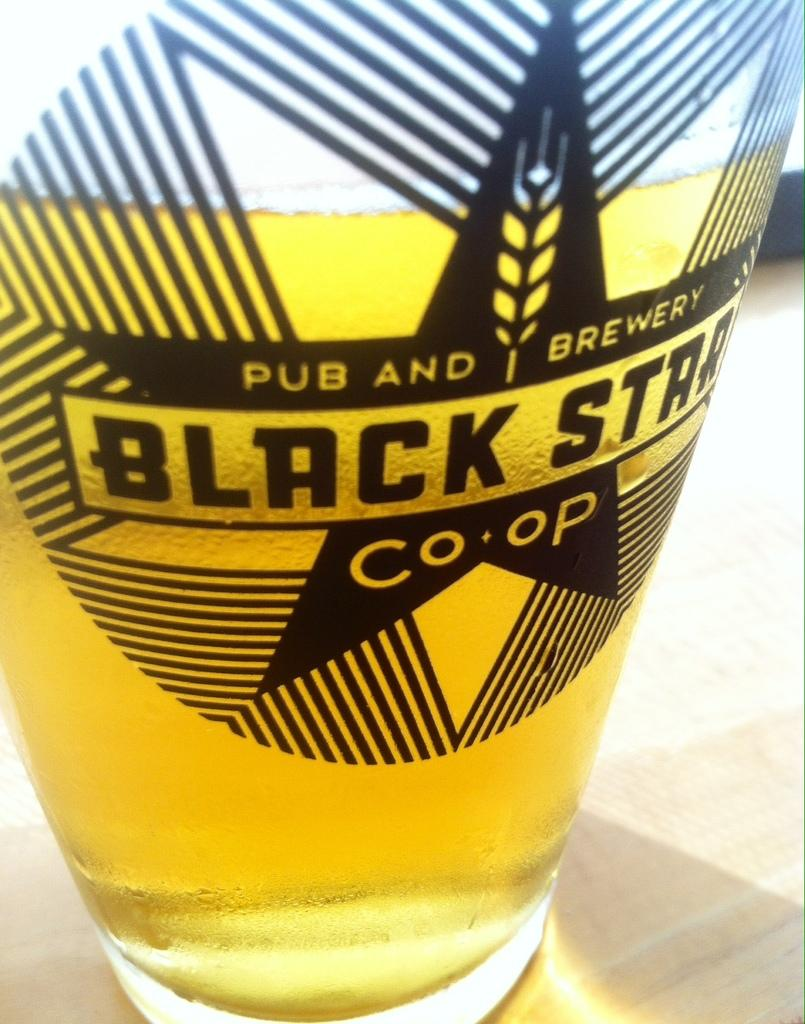<image>
Give a short and clear explanation of the subsequent image. A glass of Black Star beer has a piece of wheat on its label. 